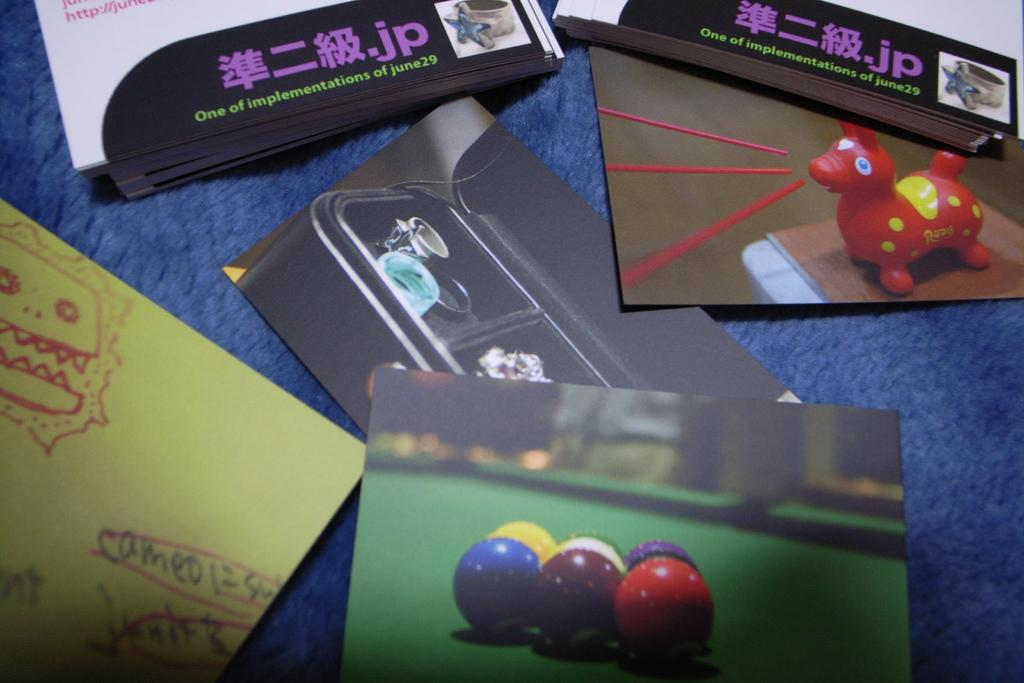What items are placed on a blue surface in the image? There are cards and magazines on a blue surface in the image. What type of game can be seen in the image? There is a pool ball table with balls in the image. Can you read any text in the image? Yes, there is some text visible in the image. What kind of figure is present in the image? There is a figure present in the image. What is the color of the box in the image? The box in the image is black. What type of toy is in the image? There is a toy in the image. Who is the manager of the club in the image? There is no club or manager mentioned or depicted in the image. How many hands are visible in the image? The image does not show any hands, so it is not possible to determine the number of hands visible. 